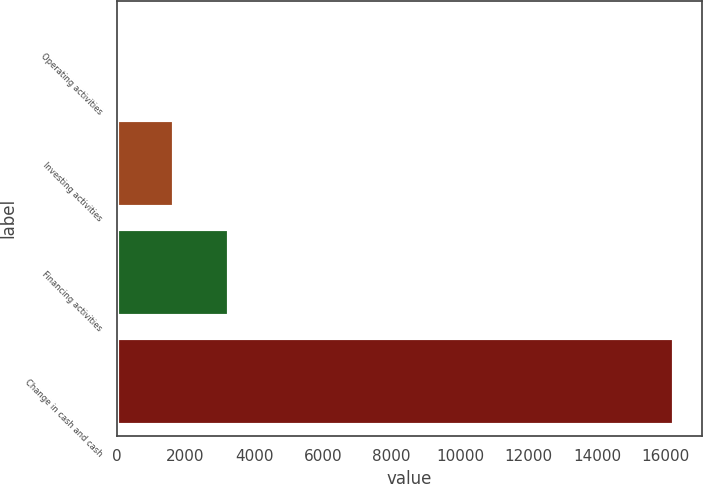Convert chart. <chart><loc_0><loc_0><loc_500><loc_500><bar_chart><fcel>Operating activities<fcel>Investing activities<fcel>Financing activities<fcel>Change in cash and cash<nl><fcel>32<fcel>1652.8<fcel>3273.6<fcel>16240<nl></chart> 